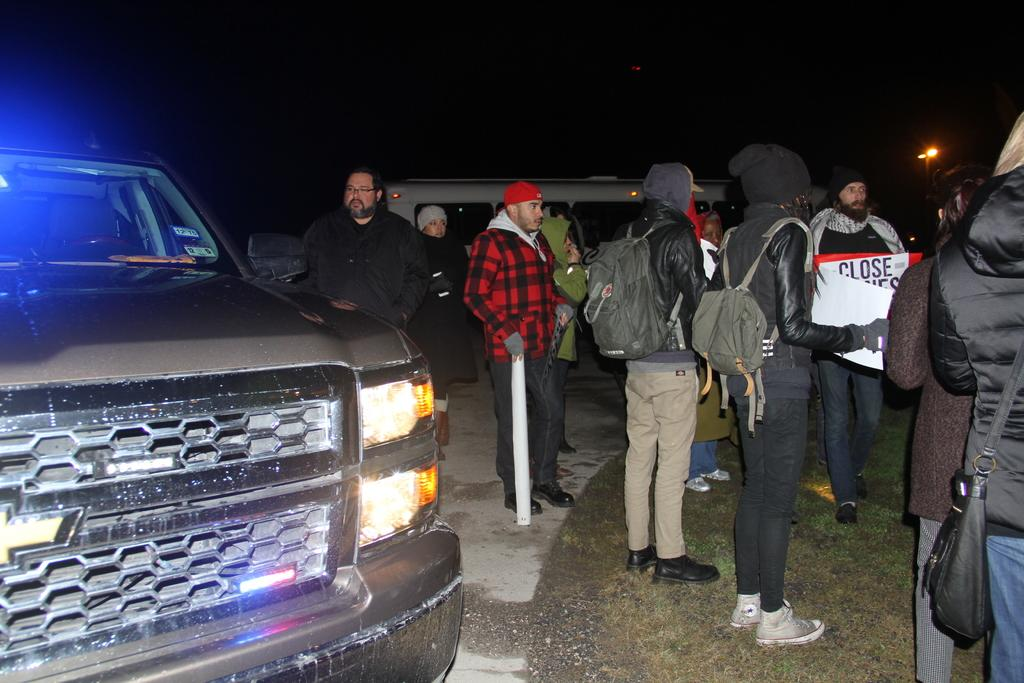What is the main subject of the image? The main subject of the image is a group of people. What are some people in the group wearing? Some people in the group are wearing bags. What else can be seen in the image besides the group of people? There are vehicles visible in the image. What can be seen in the background of the image? There is a light in the background of the image. What type of grain is being harvested by the group of people in the image? There is no grain present in the image; it features a group of people and vehicles. What is the pleasure of the group of people in the image? The image does not provide information about the pleasure or emotions of the group of people. 